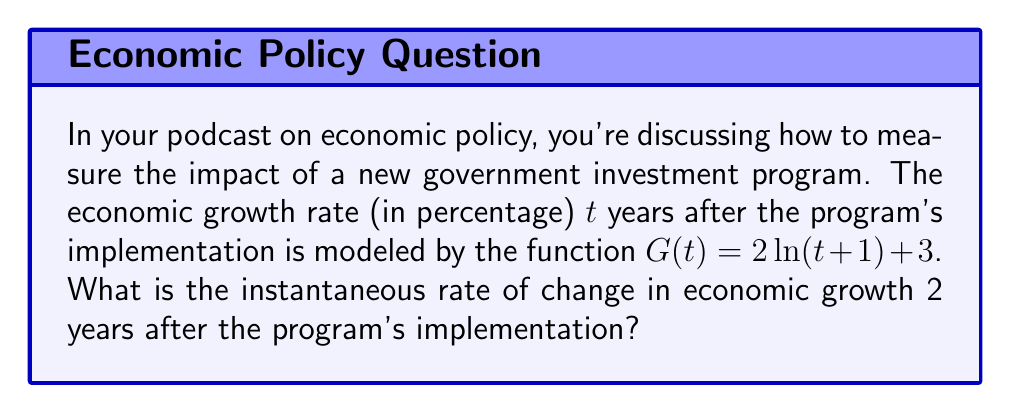Can you answer this question? To solve this problem, we need to follow these steps:

1) The rate of change in economic growth is represented by the derivative of the growth function $G(t)$.

2) Let's find the derivative of $G(t)$:
   
   $G(t) = 2\ln(t+1) + 3$
   
   $\frac{d}{dt}[G(t)] = \frac{d}{dt}[2\ln(t+1) + 3]$
   
   $G'(t) = 2 \cdot \frac{d}{dt}[\ln(t+1)] + \frac{d}{dt}[3]$
   
   $G'(t) = 2 \cdot \frac{1}{t+1} + 0$
   
   $G'(t) = \frac{2}{t+1}$

3) The question asks for the rate of change 2 years after implementation, so we need to evaluate $G'(t)$ at $t = 2$:

   $G'(2) = \frac{2}{2+1} = \frac{2}{3}$

4) Convert the fraction to a percentage:

   $\frac{2}{3} \approx 0.6667$ or about $66.67\%$

Therefore, the instantaneous rate of change in economic growth 2 years after the program's implementation is approximately 66.67% per year.
Answer: $66.67\%$ per year 